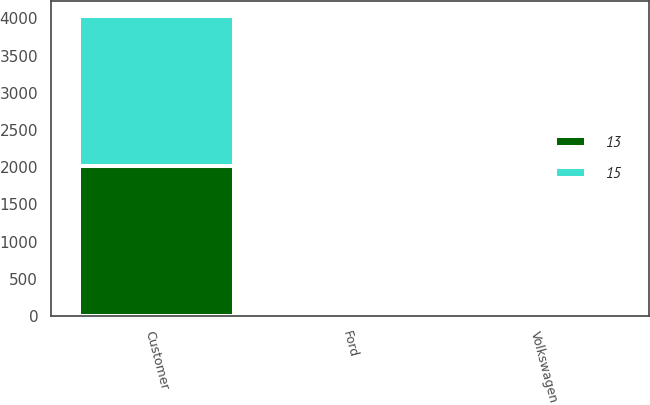Convert chart. <chart><loc_0><loc_0><loc_500><loc_500><stacked_bar_chart><ecel><fcel>Customer<fcel>Ford<fcel>Volkswagen<nl><fcel>15<fcel>2017<fcel>15<fcel>13<nl><fcel>13<fcel>2015<fcel>15<fcel>15<nl></chart> 